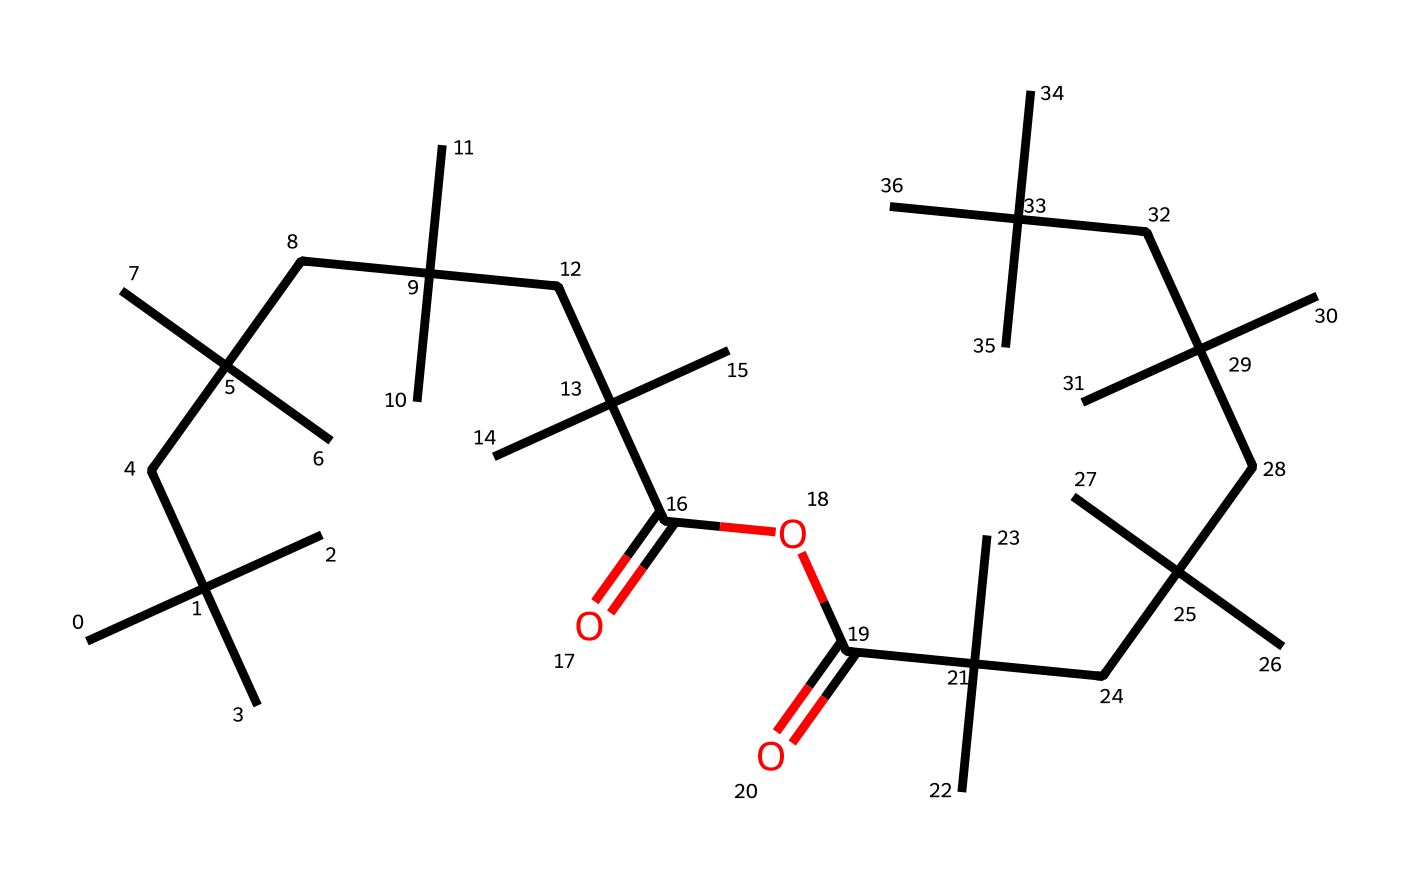What is the total number of carbon atoms in this chemical structure? By analyzing the SMILES representation, each 'C' represents a carbon atom. Counting all 'C' characters in the SMILES reveals there are a total of 36 carbon atoms.
Answer: 36 How many ester functional groups are present in this structure? The structure contains 'C(=O)O' segments, which indicate ester functional groups. Examining the structure shows there are two such segments.
Answer: 2 What type of polymer classification does this chemical belong to? The presence of ester linkages and a long aliphatic carbon chain indicates that this chemical is a type of poly(alkyl ester), commonly classified as a photodegradable polymer.
Answer: photodegradable polymer Which part of the structure contributes to its photoreactive properties? The presence of carbonyl groups (C=O) is significant for photoreactivity, as they can absorb UV light and facilitate degradation. Identifying these carbonyl functional groups in the structure indicates suitability for photoreactivity.
Answer: carbonyl groups How many different branches of carbon chains can be identified in this polymer? The structure, based on branching patterns derived from the repeating C(C)(C) units, reveals multiple branches off central carbon atoms. By analyzing the branching nature, one can count 8 major cluster branch points.
Answer: 8 What does the 'CC(C)(C)' notation in the SMILES imply about the structure? The 'CC(C)(C)' structure suggests a branching configuration typical of alkyl chains, indicating that each carbon is bonded to three other carbon atoms, contributing to both the elasticity and molecular density of the polymer.
Answer: branching structure What is the significance of the terminal '-C(=O)O' groups in the polymer? The terminal '-C(=O)O' groups signify that the polymer has ester ends, which can enhance solubility in organic solvents and contribute to the polymer's ability to break down under UV light due to the susceptibility of ester linkages to photodegradation.
Answer: solubility and photodegradation 